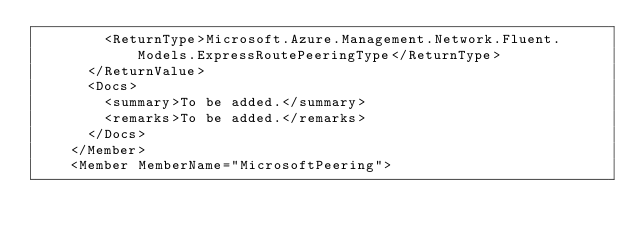<code> <loc_0><loc_0><loc_500><loc_500><_XML_>        <ReturnType>Microsoft.Azure.Management.Network.Fluent.Models.ExpressRoutePeeringType</ReturnType>
      </ReturnValue>
      <Docs>
        <summary>To be added.</summary>
        <remarks>To be added.</remarks>
      </Docs>
    </Member>
    <Member MemberName="MicrosoftPeering"></code> 